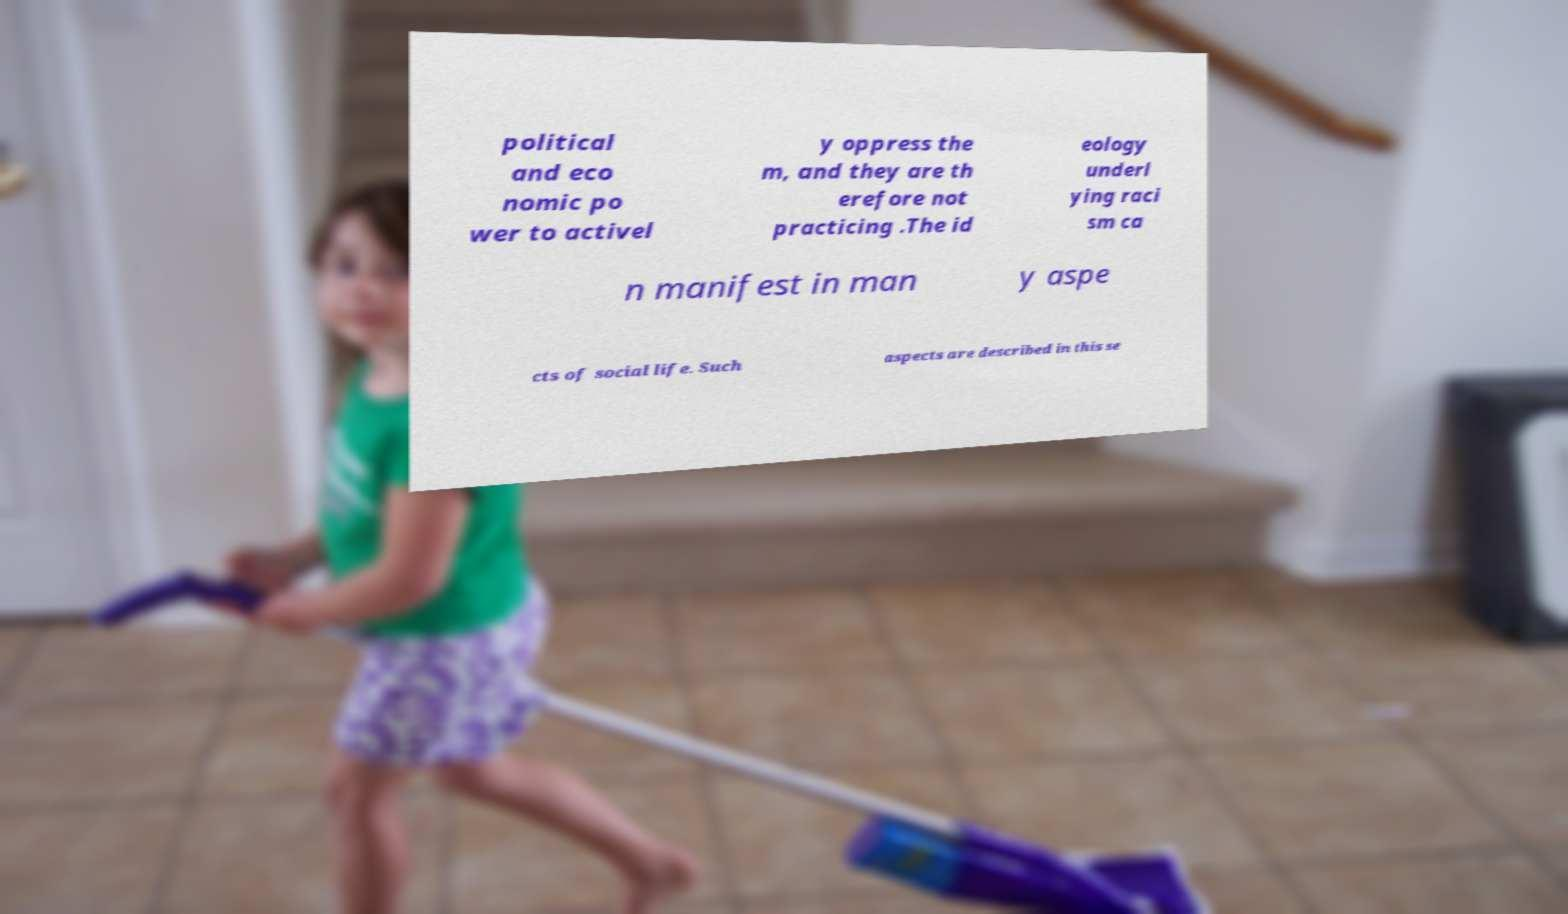Can you read and provide the text displayed in the image?This photo seems to have some interesting text. Can you extract and type it out for me? political and eco nomic po wer to activel y oppress the m, and they are th erefore not practicing .The id eology underl ying raci sm ca n manifest in man y aspe cts of social life. Such aspects are described in this se 